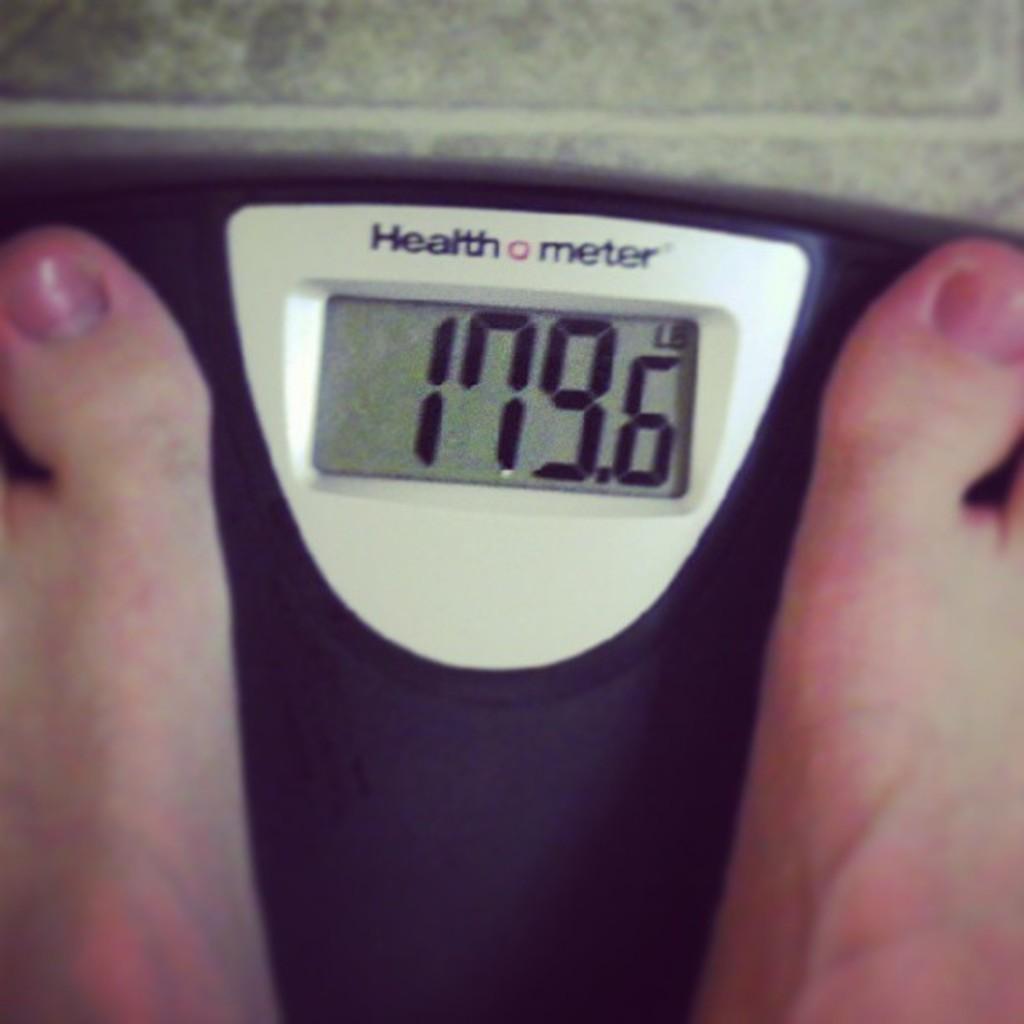What unit of measure is the weight shown in?
Ensure brevity in your answer.  Lb. How many toenails can you see?
Provide a short and direct response. Answering does not require reading text in the image. 